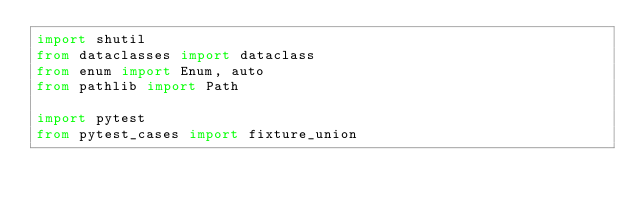<code> <loc_0><loc_0><loc_500><loc_500><_Python_>import shutil
from dataclasses import dataclass
from enum import Enum, auto
from pathlib import Path

import pytest
from pytest_cases import fixture_union

</code> 